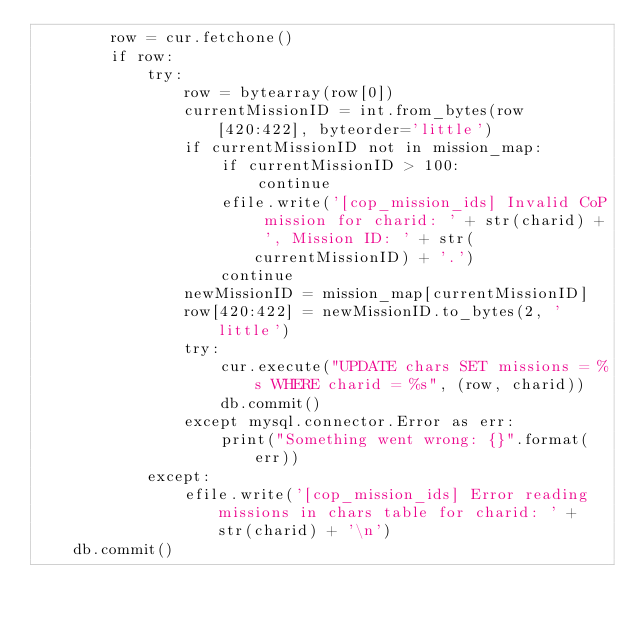Convert code to text. <code><loc_0><loc_0><loc_500><loc_500><_Python_>        row = cur.fetchone()
        if row:
            try:
                row = bytearray(row[0])
                currentMissionID = int.from_bytes(row[420:422], byteorder='little')
                if currentMissionID not in mission_map:
                    if currentMissionID > 100:
                        continue
                    efile.write('[cop_mission_ids] Invalid CoP mission for charid: ' + str(charid) + ', Mission ID: ' + str(currentMissionID) + '.')
                    continue
                newMissionID = mission_map[currentMissionID]
                row[420:422] = newMissionID.to_bytes(2, 'little')
                try:
                    cur.execute("UPDATE chars SET missions = %s WHERE charid = %s", (row, charid))
                    db.commit()
                except mysql.connector.Error as err:
                    print("Something went wrong: {}".format(err))
            except:
                efile.write('[cop_mission_ids] Error reading missions in chars table for charid: ' + str(charid) + '\n')
    db.commit()</code> 